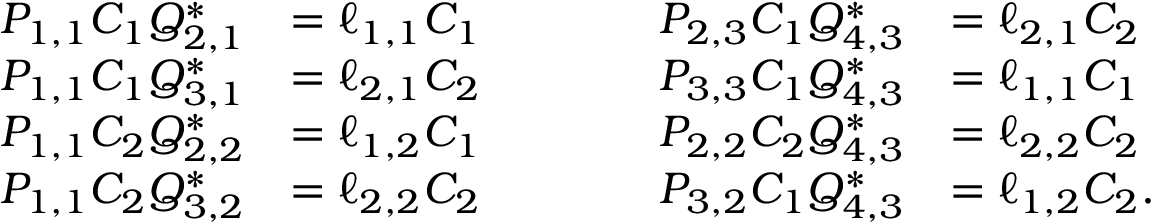Convert formula to latex. <formula><loc_0><loc_0><loc_500><loc_500>\begin{array} { r l } { P _ { 1 , 1 } C _ { 1 } Q _ { 2 , 1 } ^ { * } } & { = \ell _ { 1 , 1 } C _ { 1 } } \\ { P _ { 1 , 1 } C _ { 1 } Q _ { 3 , 1 } ^ { * } } & { = \ell _ { 2 , 1 } C _ { 2 } } \\ { P _ { 1 , 1 } C _ { 2 } Q _ { 2 , 2 } ^ { * } } & { = \ell _ { 1 , 2 } C _ { 1 } } \\ { P _ { 1 , 1 } C _ { 2 } Q _ { 3 , 2 } ^ { * } } & { = \ell _ { 2 , 2 } C _ { 2 } } \end{array} \quad \begin{array} { r l } { P _ { 2 , 3 } C _ { 1 } Q _ { 4 , 3 } ^ { * } } & { = \ell _ { 2 , 1 } C _ { 2 } } \\ { P _ { 3 , 3 } C _ { 1 } Q _ { 4 , 3 } ^ { * } } & { = \ell _ { 1 , 1 } C _ { 1 } } \\ { P _ { 2 , 2 } C _ { 2 } Q _ { 4 , 3 } ^ { * } } & { = \ell _ { 2 , 2 } C _ { 2 } } \\ { P _ { 3 , 2 } C _ { 1 } Q _ { 4 , 3 } ^ { * } } & { = \ell _ { 1 , 2 } C _ { 2 } . } \end{array}</formula> 